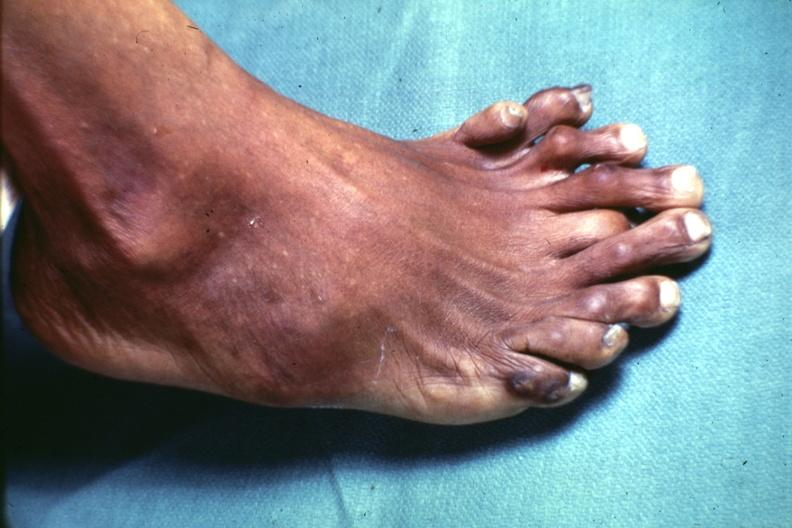what does this image show?
Answer the question using a single word or phrase. View from dorsum of foot which has at least 9 toes 